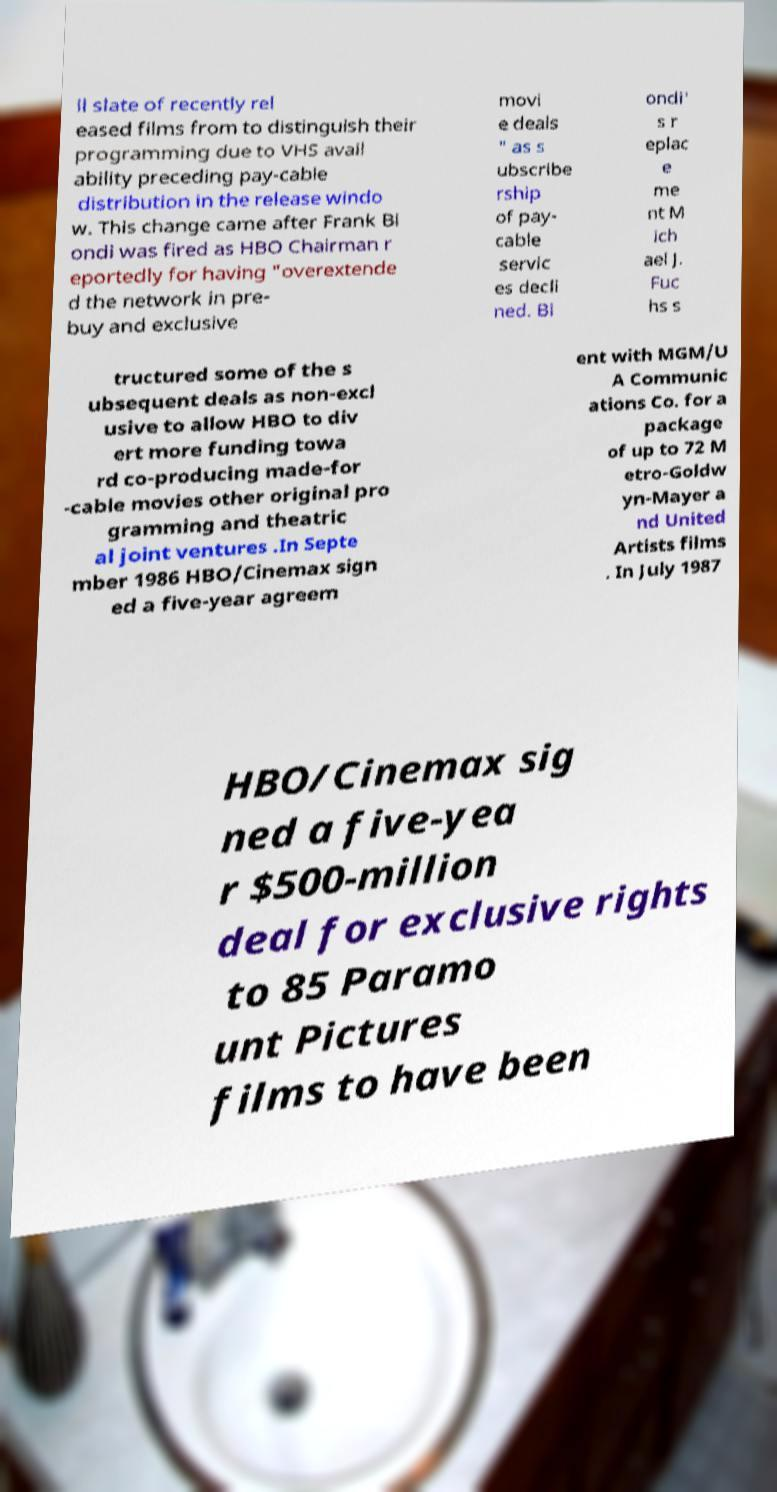Please read and relay the text visible in this image. What does it say? ll slate of recently rel eased films from to distinguish their programming due to VHS avail ability preceding pay-cable distribution in the release windo w. This change came after Frank Bi ondi was fired as HBO Chairman r eportedly for having "overextende d the network in pre- buy and exclusive movi e deals " as s ubscribe rship of pay- cable servic es decli ned. Bi ondi' s r eplac e me nt M ich ael J. Fuc hs s tructured some of the s ubsequent deals as non-excl usive to allow HBO to div ert more funding towa rd co-producing made-for -cable movies other original pro gramming and theatric al joint ventures .In Septe mber 1986 HBO/Cinemax sign ed a five-year agreem ent with MGM/U A Communic ations Co. for a package of up to 72 M etro-Goldw yn-Mayer a nd United Artists films . In July 1987 HBO/Cinemax sig ned a five-yea r $500-million deal for exclusive rights to 85 Paramo unt Pictures films to have been 